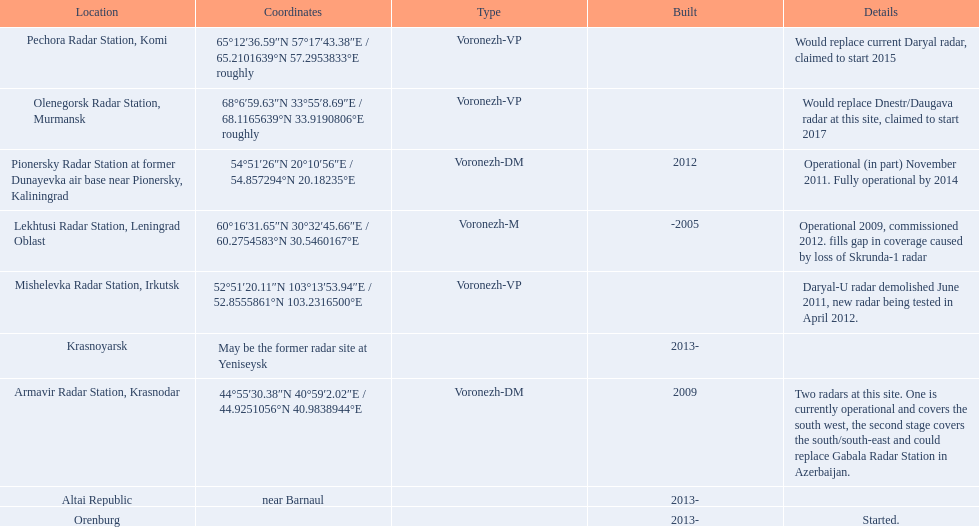What are the list of radar locations? Lekhtusi Radar Station, Leningrad Oblast, Armavir Radar Station, Krasnodar, Pionersky Radar Station at former Dunayevka air base near Pionersky, Kaliningrad, Mishelevka Radar Station, Irkutsk, Pechora Radar Station, Komi, Olenegorsk Radar Station, Murmansk, Krasnoyarsk, Altai Republic, Orenburg. Which of these are claimed to start in 2015? Pechora Radar Station, Komi. 